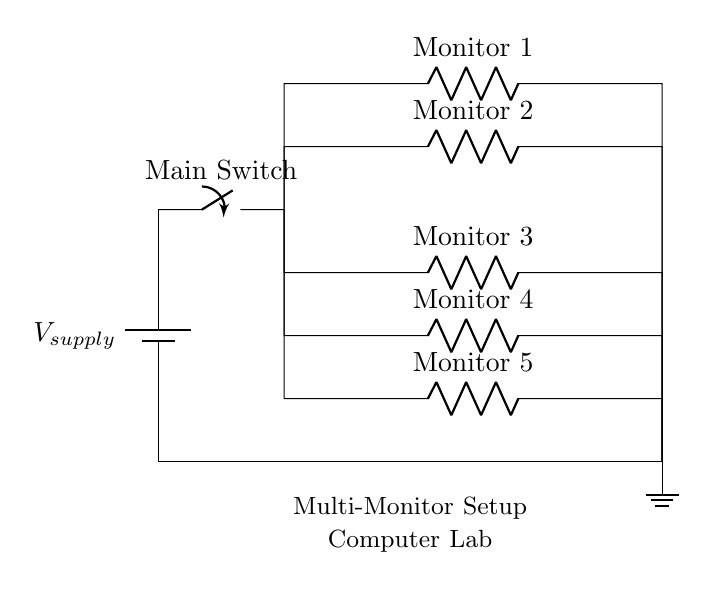What is the type of circuit shown? The diagram represents a parallel circuit, where multiple components, in this case, monitors, are connected across the same voltage source. This is evident because all the monitors share the same voltage supply from the single battery source.
Answer: Parallel How many monitors are connected in this setup? The circuit diagram clearly shows five resistors labeled as Monitor 1 through Monitor 5, indicating that there are five monitors connected in the setup.
Answer: Five What is the main function of the switch in this circuit? The main switch serves to control the power supply to the entire circuit. When the switch is open, no current flows to the monitors; when closed, the current is allowed to flow, powering all connected monitors simultaneously.
Answer: Control power What can you say about the voltage across each monitor? In a parallel circuit, the voltage across each component is the same as the supply voltage, meaning each monitor experiences the same potential difference from the battery source. Therefore, if the supply voltage is specified, that same voltage applies to all monitors.
Answer: Same as supply If one monitor fails, what happens to the others? In a parallel circuit, if one branch (monitor) fails, the other branches remain functional. This is due to each monitor being independently connected to the voltage supply, thus preserving the operation of the remaining monitors.
Answer: Others remain functional What component is used to represent each monitor? Each monitor is represented by a resistor in the circuit diagram, which illustrates their role as loads that receive electric power and convert it into another form of energy, such as light in the case of monitors.
Answer: Resistor What is the significance of the ground in this circuit? The ground serves as a reference point for the voltage in the circuit, completing the circuit path for current to return to the source. It establishes a common potential for all components in the circuit.
Answer: Reference point 